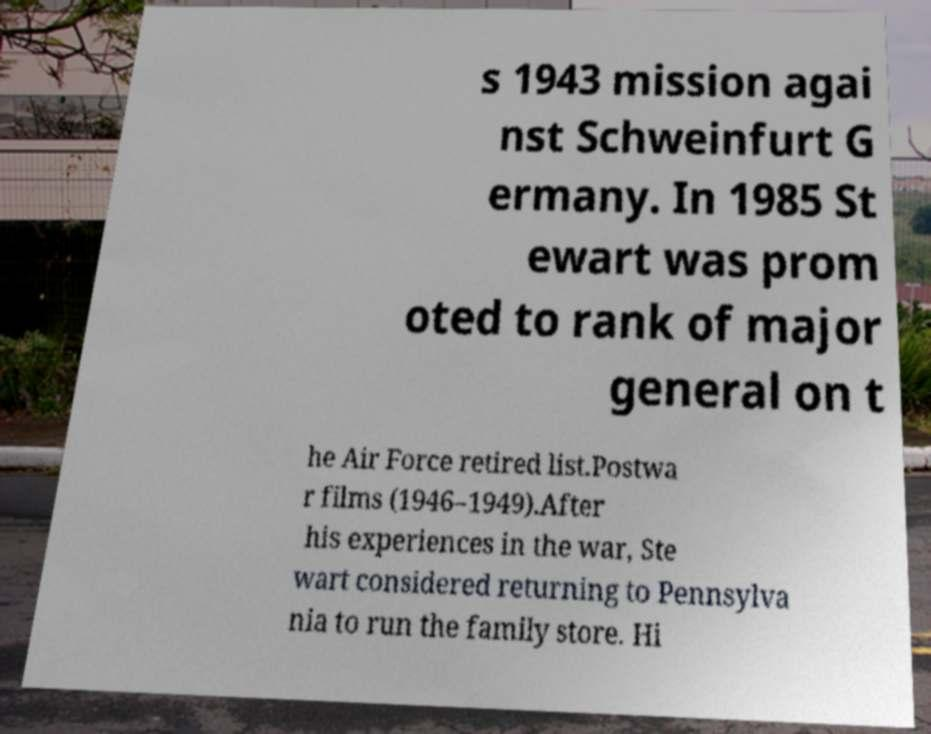Could you extract and type out the text from this image? s 1943 mission agai nst Schweinfurt G ermany. In 1985 St ewart was prom oted to rank of major general on t he Air Force retired list.Postwa r films (1946–1949).After his experiences in the war, Ste wart considered returning to Pennsylva nia to run the family store. Hi 